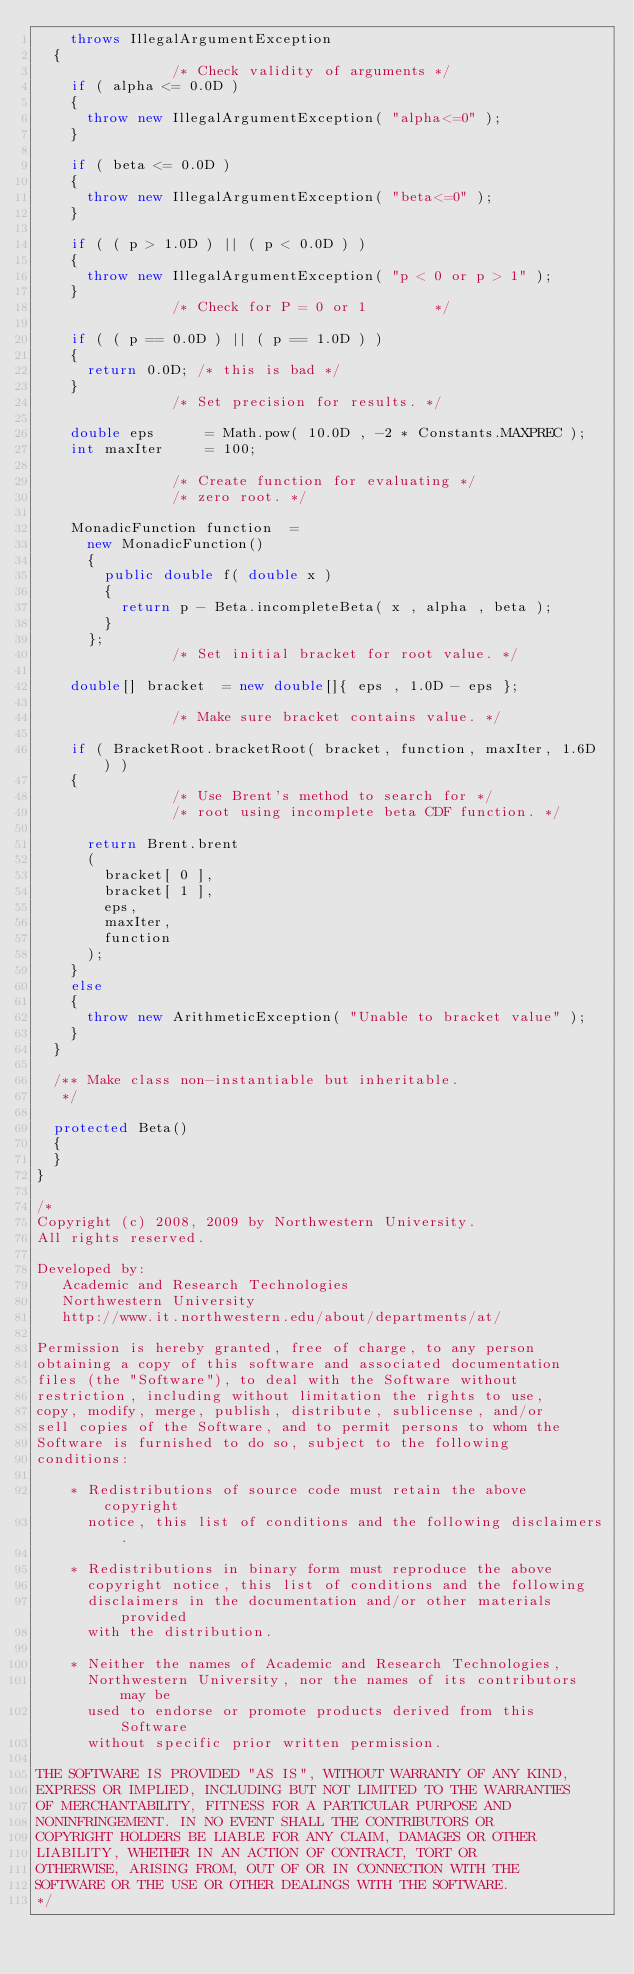<code> <loc_0><loc_0><loc_500><loc_500><_Java_>		throws IllegalArgumentException
	{
								/* Check validity of arguments */
		if ( alpha <= 0.0D )
		{
			throw new IllegalArgumentException( "alpha<=0" );
		}

		if ( beta <= 0.0D )
		{
			throw new IllegalArgumentException( "beta<=0" );
		}

		if ( ( p > 1.0D ) || ( p < 0.0D ) )
		{
			throw new IllegalArgumentException( "p < 0 or p > 1" );
		}
								/* Check for P = 0 or 1        */

		if ( ( p == 0.0D ) || ( p == 1.0D ) )
		{
			return 0.0D; /* this is bad */
		}
								/* Set precision for results. */

		double eps			= Math.pow( 10.0D , -2 * Constants.MAXPREC );
		int maxIter			= 100;

								/* Create function for evaluating */
								/* zero root. */

		MonadicFunction function	=
			new MonadicFunction()
			{
				public double f( double x )
				{
					return p - Beta.incompleteBeta( x , alpha , beta );
				}
			};
								/* Set initial bracket for root value. */

		double[] bracket	= new double[]{ eps , 1.0D - eps };

								/* Make sure bracket contains value. */

		if ( BracketRoot.bracketRoot( bracket, function, maxIter, 1.6D ) )
		{
								/* Use Brent's method to search for */
								/* root using incomplete beta CDF function. */

			return Brent.brent
			(
				bracket[ 0 ],
				bracket[ 1 ],
				eps,
				maxIter,
				function
			);
		}
		else
		{
			throw new ArithmeticException( "Unable to bracket value" );
		}
	}

	/**	Make class non-instantiable but inheritable.
	 */

	protected Beta()
	{
	}
}

/*
Copyright (c) 2008, 2009 by Northwestern University.
All rights reserved.

Developed by:
   Academic and Research Technologies
   Northwestern University
   http://www.it.northwestern.edu/about/departments/at/

Permission is hereby granted, free of charge, to any person
obtaining a copy of this software and associated documentation
files (the "Software"), to deal with the Software without
restriction, including without limitation the rights to use,
copy, modify, merge, publish, distribute, sublicense, and/or
sell copies of the Software, and to permit persons to whom the
Software is furnished to do so, subject to the following
conditions:

    * Redistributions of source code must retain the above copyright
      notice, this list of conditions and the following disclaimers.

    * Redistributions in binary form must reproduce the above
      copyright notice, this list of conditions and the following
      disclaimers in the documentation and/or other materials provided
      with the distribution.

    * Neither the names of Academic and Research Technologies,
      Northwestern University, nor the names of its contributors may be
      used to endorse or promote products derived from this Software
      without specific prior written permission.

THE SOFTWARE IS PROVIDED "AS IS", WITHOUT WARRANTY OF ANY KIND,
EXPRESS OR IMPLIED, INCLUDING BUT NOT LIMITED TO THE WARRANTIES
OF MERCHANTABILITY, FITNESS FOR A PARTICULAR PURPOSE AND
NONINFRINGEMENT. IN NO EVENT SHALL THE CONTRIBUTORS OR
COPYRIGHT HOLDERS BE LIABLE FOR ANY CLAIM, DAMAGES OR OTHER
LIABILITY, WHETHER IN AN ACTION OF CONTRACT, TORT OR
OTHERWISE, ARISING FROM, OUT OF OR IN CONNECTION WITH THE
SOFTWARE OR THE USE OR OTHER DEALINGS WITH THE SOFTWARE.
*/


</code> 